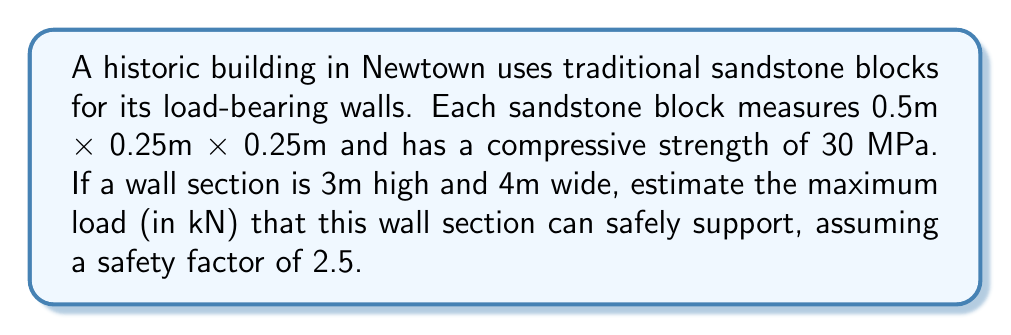Solve this math problem. To solve this problem, we'll follow these steps:

1. Calculate the cross-sectional area of the wall:
   Width = 4m, Height = 0.25m (thickness of one block)
   Area = $4 \text{ m} \times 0.25 \text{ m} = 1 \text{ m}^2$

2. Convert the compressive strength from MPa to kN/m²:
   $30 \text{ MPa} = 30,000 \text{ kN/m}^2$

3. Calculate the maximum theoretical load:
   Max Load = Compressive Strength × Area
   $\text{Max Load} = 30,000 \text{ kN/m}^2 \times 1 \text{ m}^2 = 30,000 \text{ kN}$

4. Apply the safety factor:
   Safe Load = Max Load ÷ Safety Factor
   $\text{Safe Load} = \frac{30,000 \text{ kN}}{2.5} = 12,000 \text{ kN}$

Therefore, the maximum load that the wall section can safely support is 12,000 kN.
Answer: 12,000 kN 